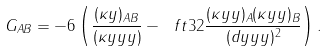Convert formula to latex. <formula><loc_0><loc_0><loc_500><loc_500>G _ { A B } = - 6 \left ( \frac { ( \kappa y ) _ { A B } } { ( \kappa y y y ) } - \ f t 3 2 \frac { ( \kappa y y ) _ { A } ( \kappa y y ) _ { B } } { ( d y y y ) ^ { 2 } } \right ) .</formula> 